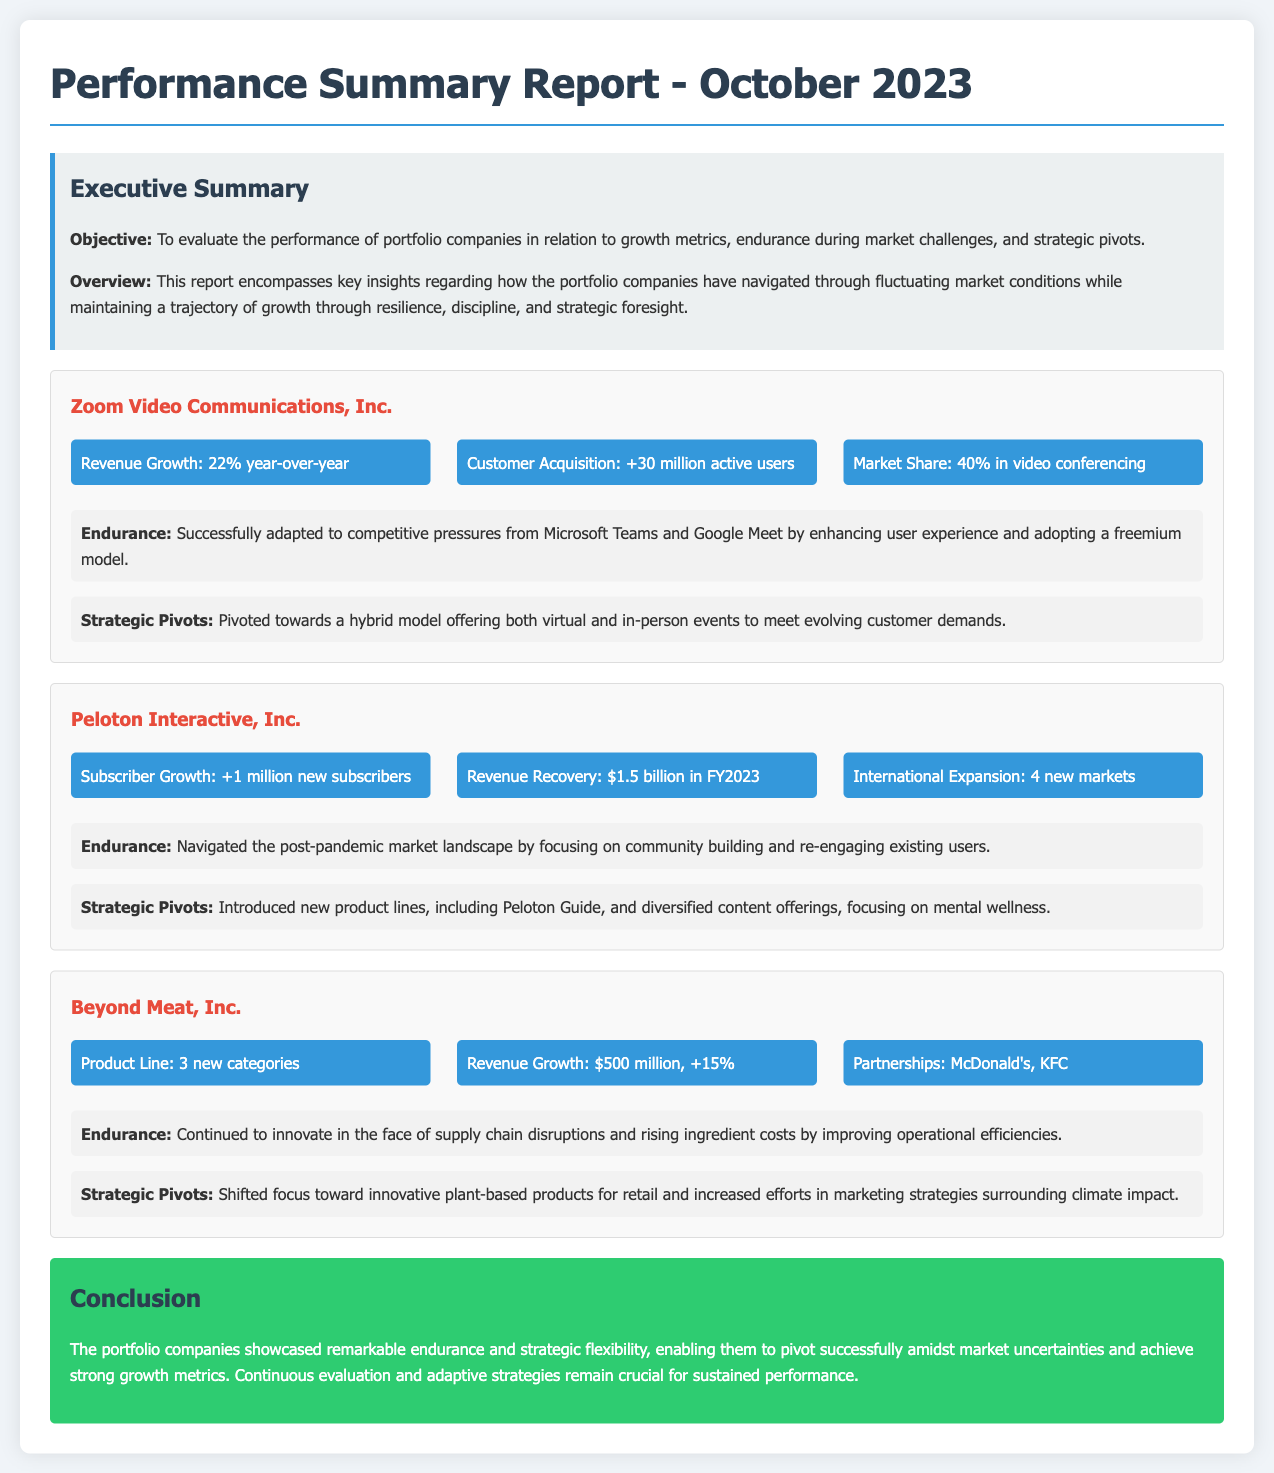What is the revenue growth percentage for Zoom Video Communications, Inc.? The revenue growth for Zoom Video Communications, Inc. is stated as 22% year-over-year.
Answer: 22% How many new subscribers did Peloton Interactive, Inc. gain? Peloton Interactive, Inc. gained 1 million new subscribers.
Answer: 1 million What is the revenue for Beyond Meat, Inc. in FY2023? The revenue for Beyond Meat, Inc. in FY2023 is reported to be $500 million.
Answer: $500 million Which company had a revenue recovery of $1.5 billion? The company that had a revenue recovery of $1.5 billion is Peloton Interactive, Inc.
Answer: Peloton Interactive, Inc What strategic pivot did Zoom implement? Zoom pivoted towards a hybrid model offering both virtual and in-person events.
Answer: Hybrid model What are the new product lines introduced by Peloton? Peloton introduced new product lines, including Peloton Guide.
Answer: Peloton Guide What is the market share of Zoom in video conferencing? The market share of Zoom in video conferencing is reported to be 40%.
Answer: 40% How many new markets did Beyond Meat expand into? Beyond Meat expanded into 4 new markets.
Answer: 4 What was emphasized in the conclusion of the report? The conclusion emphasized remarkable endurance and strategic flexibility of the portfolio companies.
Answer: Endurance and strategic flexibility 